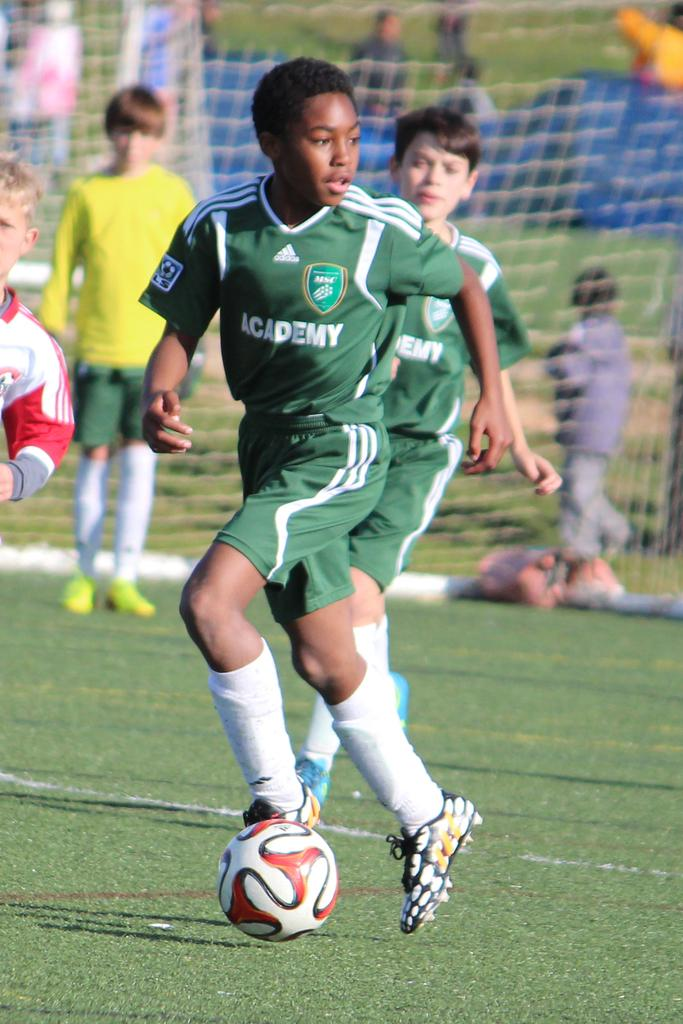What are the two persons in the image doing? The two persons in the image are playing football. Where does the scene take place? The scene takes place in a stadium. Can you describe the people standing at the back side of the image? There are people standing at the back side of the image. What is used to catch the football in the image? There is a net in the image to catch the football. What is the main object being used in the game? There is a football in the image. What type of drum can be heard playing in the background of the image? There is no drum or sound present in the image; it is a still photograph. How is the glue being used in the image? There is no glue present in the image. 